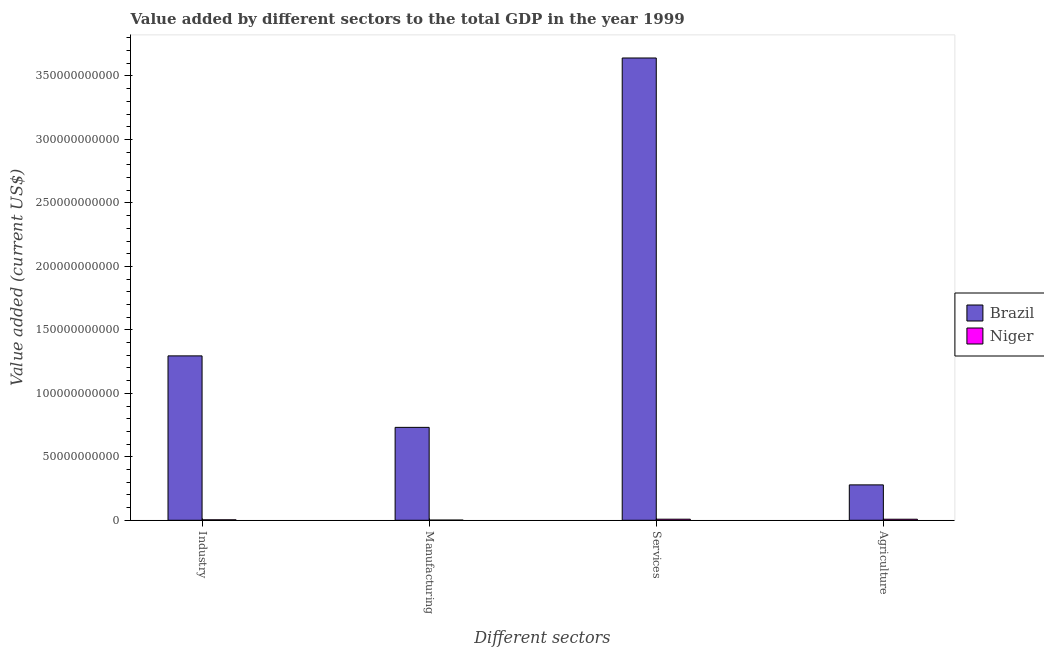How many bars are there on the 2nd tick from the left?
Offer a terse response. 2. What is the label of the 1st group of bars from the left?
Make the answer very short. Industry. What is the value added by manufacturing sector in Brazil?
Keep it short and to the point. 7.32e+1. Across all countries, what is the maximum value added by services sector?
Make the answer very short. 3.64e+11. Across all countries, what is the minimum value added by services sector?
Keep it short and to the point. 8.50e+08. In which country was the value added by services sector maximum?
Your answer should be compact. Brazil. In which country was the value added by industrial sector minimum?
Make the answer very short. Niger. What is the total value added by agricultural sector in the graph?
Make the answer very short. 2.87e+1. What is the difference between the value added by services sector in Niger and that in Brazil?
Offer a terse response. -3.63e+11. What is the difference between the value added by services sector in Brazil and the value added by agricultural sector in Niger?
Your answer should be compact. 3.63e+11. What is the average value added by services sector per country?
Ensure brevity in your answer.  1.83e+11. What is the difference between the value added by manufacturing sector and value added by agricultural sector in Brazil?
Ensure brevity in your answer.  4.53e+1. In how many countries, is the value added by agricultural sector greater than 240000000000 US$?
Your response must be concise. 0. What is the ratio of the value added by services sector in Niger to that in Brazil?
Offer a terse response. 0. Is the value added by services sector in Niger less than that in Brazil?
Ensure brevity in your answer.  Yes. What is the difference between the highest and the second highest value added by manufacturing sector?
Provide a short and direct response. 7.31e+1. What is the difference between the highest and the lowest value added by agricultural sector?
Your response must be concise. 2.70e+1. In how many countries, is the value added by services sector greater than the average value added by services sector taken over all countries?
Offer a terse response. 1. Is it the case that in every country, the sum of the value added by agricultural sector and value added by industrial sector is greater than the sum of value added by manufacturing sector and value added by services sector?
Offer a terse response. No. What does the 2nd bar from the left in Industry represents?
Offer a terse response. Niger. What does the 2nd bar from the right in Manufacturing represents?
Keep it short and to the point. Brazil. Is it the case that in every country, the sum of the value added by industrial sector and value added by manufacturing sector is greater than the value added by services sector?
Your response must be concise. No. How many bars are there?
Your answer should be very brief. 8. Are all the bars in the graph horizontal?
Give a very brief answer. No. Are the values on the major ticks of Y-axis written in scientific E-notation?
Your answer should be very brief. No. Does the graph contain any zero values?
Make the answer very short. No. Does the graph contain grids?
Make the answer very short. No. How many legend labels are there?
Your answer should be very brief. 2. How are the legend labels stacked?
Your answer should be very brief. Vertical. What is the title of the graph?
Offer a very short reply. Value added by different sectors to the total GDP in the year 1999. What is the label or title of the X-axis?
Make the answer very short. Different sectors. What is the label or title of the Y-axis?
Keep it short and to the point. Value added (current US$). What is the Value added (current US$) of Brazil in Industry?
Offer a very short reply. 1.30e+11. What is the Value added (current US$) in Niger in Industry?
Your response must be concise. 3.46e+08. What is the Value added (current US$) in Brazil in Manufacturing?
Make the answer very short. 7.32e+1. What is the Value added (current US$) in Niger in Manufacturing?
Your answer should be very brief. 1.31e+08. What is the Value added (current US$) in Brazil in Services?
Offer a terse response. 3.64e+11. What is the Value added (current US$) in Niger in Services?
Your answer should be very brief. 8.50e+08. What is the Value added (current US$) in Brazil in Agriculture?
Offer a terse response. 2.79e+1. What is the Value added (current US$) of Niger in Agriculture?
Provide a short and direct response. 8.22e+08. Across all Different sectors, what is the maximum Value added (current US$) of Brazil?
Keep it short and to the point. 3.64e+11. Across all Different sectors, what is the maximum Value added (current US$) in Niger?
Give a very brief answer. 8.50e+08. Across all Different sectors, what is the minimum Value added (current US$) in Brazil?
Provide a short and direct response. 2.79e+1. Across all Different sectors, what is the minimum Value added (current US$) in Niger?
Ensure brevity in your answer.  1.31e+08. What is the total Value added (current US$) in Brazil in the graph?
Make the answer very short. 5.95e+11. What is the total Value added (current US$) of Niger in the graph?
Offer a terse response. 2.15e+09. What is the difference between the Value added (current US$) of Brazil in Industry and that in Manufacturing?
Offer a very short reply. 5.63e+1. What is the difference between the Value added (current US$) in Niger in Industry and that in Manufacturing?
Your answer should be compact. 2.15e+08. What is the difference between the Value added (current US$) of Brazil in Industry and that in Services?
Provide a short and direct response. -2.35e+11. What is the difference between the Value added (current US$) of Niger in Industry and that in Services?
Keep it short and to the point. -5.04e+08. What is the difference between the Value added (current US$) in Brazil in Industry and that in Agriculture?
Keep it short and to the point. 1.02e+11. What is the difference between the Value added (current US$) in Niger in Industry and that in Agriculture?
Keep it short and to the point. -4.76e+08. What is the difference between the Value added (current US$) in Brazil in Manufacturing and that in Services?
Provide a succinct answer. -2.91e+11. What is the difference between the Value added (current US$) of Niger in Manufacturing and that in Services?
Give a very brief answer. -7.19e+08. What is the difference between the Value added (current US$) in Brazil in Manufacturing and that in Agriculture?
Provide a succinct answer. 4.53e+1. What is the difference between the Value added (current US$) in Niger in Manufacturing and that in Agriculture?
Keep it short and to the point. -6.91e+08. What is the difference between the Value added (current US$) in Brazil in Services and that in Agriculture?
Keep it short and to the point. 3.36e+11. What is the difference between the Value added (current US$) in Niger in Services and that in Agriculture?
Provide a succinct answer. 2.79e+07. What is the difference between the Value added (current US$) in Brazil in Industry and the Value added (current US$) in Niger in Manufacturing?
Your response must be concise. 1.29e+11. What is the difference between the Value added (current US$) of Brazil in Industry and the Value added (current US$) of Niger in Services?
Your answer should be compact. 1.29e+11. What is the difference between the Value added (current US$) of Brazil in Industry and the Value added (current US$) of Niger in Agriculture?
Your answer should be very brief. 1.29e+11. What is the difference between the Value added (current US$) in Brazil in Manufacturing and the Value added (current US$) in Niger in Services?
Give a very brief answer. 7.23e+1. What is the difference between the Value added (current US$) in Brazil in Manufacturing and the Value added (current US$) in Niger in Agriculture?
Offer a terse response. 7.24e+1. What is the difference between the Value added (current US$) in Brazil in Services and the Value added (current US$) in Niger in Agriculture?
Your answer should be compact. 3.63e+11. What is the average Value added (current US$) of Brazil per Different sectors?
Your response must be concise. 1.49e+11. What is the average Value added (current US$) in Niger per Different sectors?
Your answer should be very brief. 5.37e+08. What is the difference between the Value added (current US$) in Brazil and Value added (current US$) in Niger in Industry?
Give a very brief answer. 1.29e+11. What is the difference between the Value added (current US$) in Brazil and Value added (current US$) in Niger in Manufacturing?
Provide a succinct answer. 7.31e+1. What is the difference between the Value added (current US$) of Brazil and Value added (current US$) of Niger in Services?
Provide a short and direct response. 3.63e+11. What is the difference between the Value added (current US$) in Brazil and Value added (current US$) in Niger in Agriculture?
Your answer should be very brief. 2.70e+1. What is the ratio of the Value added (current US$) of Brazil in Industry to that in Manufacturing?
Offer a terse response. 1.77. What is the ratio of the Value added (current US$) of Niger in Industry to that in Manufacturing?
Your answer should be compact. 2.64. What is the ratio of the Value added (current US$) in Brazil in Industry to that in Services?
Offer a terse response. 0.36. What is the ratio of the Value added (current US$) of Niger in Industry to that in Services?
Offer a terse response. 0.41. What is the ratio of the Value added (current US$) of Brazil in Industry to that in Agriculture?
Make the answer very short. 4.65. What is the ratio of the Value added (current US$) in Niger in Industry to that in Agriculture?
Give a very brief answer. 0.42. What is the ratio of the Value added (current US$) of Brazil in Manufacturing to that in Services?
Keep it short and to the point. 0.2. What is the ratio of the Value added (current US$) in Niger in Manufacturing to that in Services?
Your response must be concise. 0.15. What is the ratio of the Value added (current US$) of Brazil in Manufacturing to that in Agriculture?
Keep it short and to the point. 2.63. What is the ratio of the Value added (current US$) of Niger in Manufacturing to that in Agriculture?
Give a very brief answer. 0.16. What is the ratio of the Value added (current US$) in Brazil in Services to that in Agriculture?
Provide a short and direct response. 13.07. What is the ratio of the Value added (current US$) of Niger in Services to that in Agriculture?
Keep it short and to the point. 1.03. What is the difference between the highest and the second highest Value added (current US$) of Brazil?
Give a very brief answer. 2.35e+11. What is the difference between the highest and the second highest Value added (current US$) of Niger?
Your answer should be very brief. 2.79e+07. What is the difference between the highest and the lowest Value added (current US$) in Brazil?
Offer a terse response. 3.36e+11. What is the difference between the highest and the lowest Value added (current US$) in Niger?
Your response must be concise. 7.19e+08. 